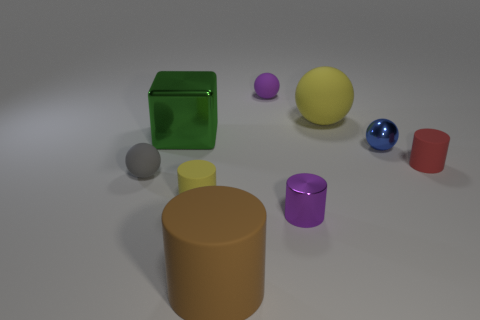Subtract all gray matte balls. How many balls are left? 3 Subtract 2 balls. How many balls are left? 2 Subtract all yellow balls. How many balls are left? 3 Add 6 red matte objects. How many red matte objects exist? 7 Subtract 0 red cubes. How many objects are left? 9 Subtract all cylinders. How many objects are left? 5 Subtract all brown balls. Subtract all red blocks. How many balls are left? 4 Subtract all yellow rubber cylinders. Subtract all tiny gray spheres. How many objects are left? 7 Add 4 small purple things. How many small purple things are left? 6 